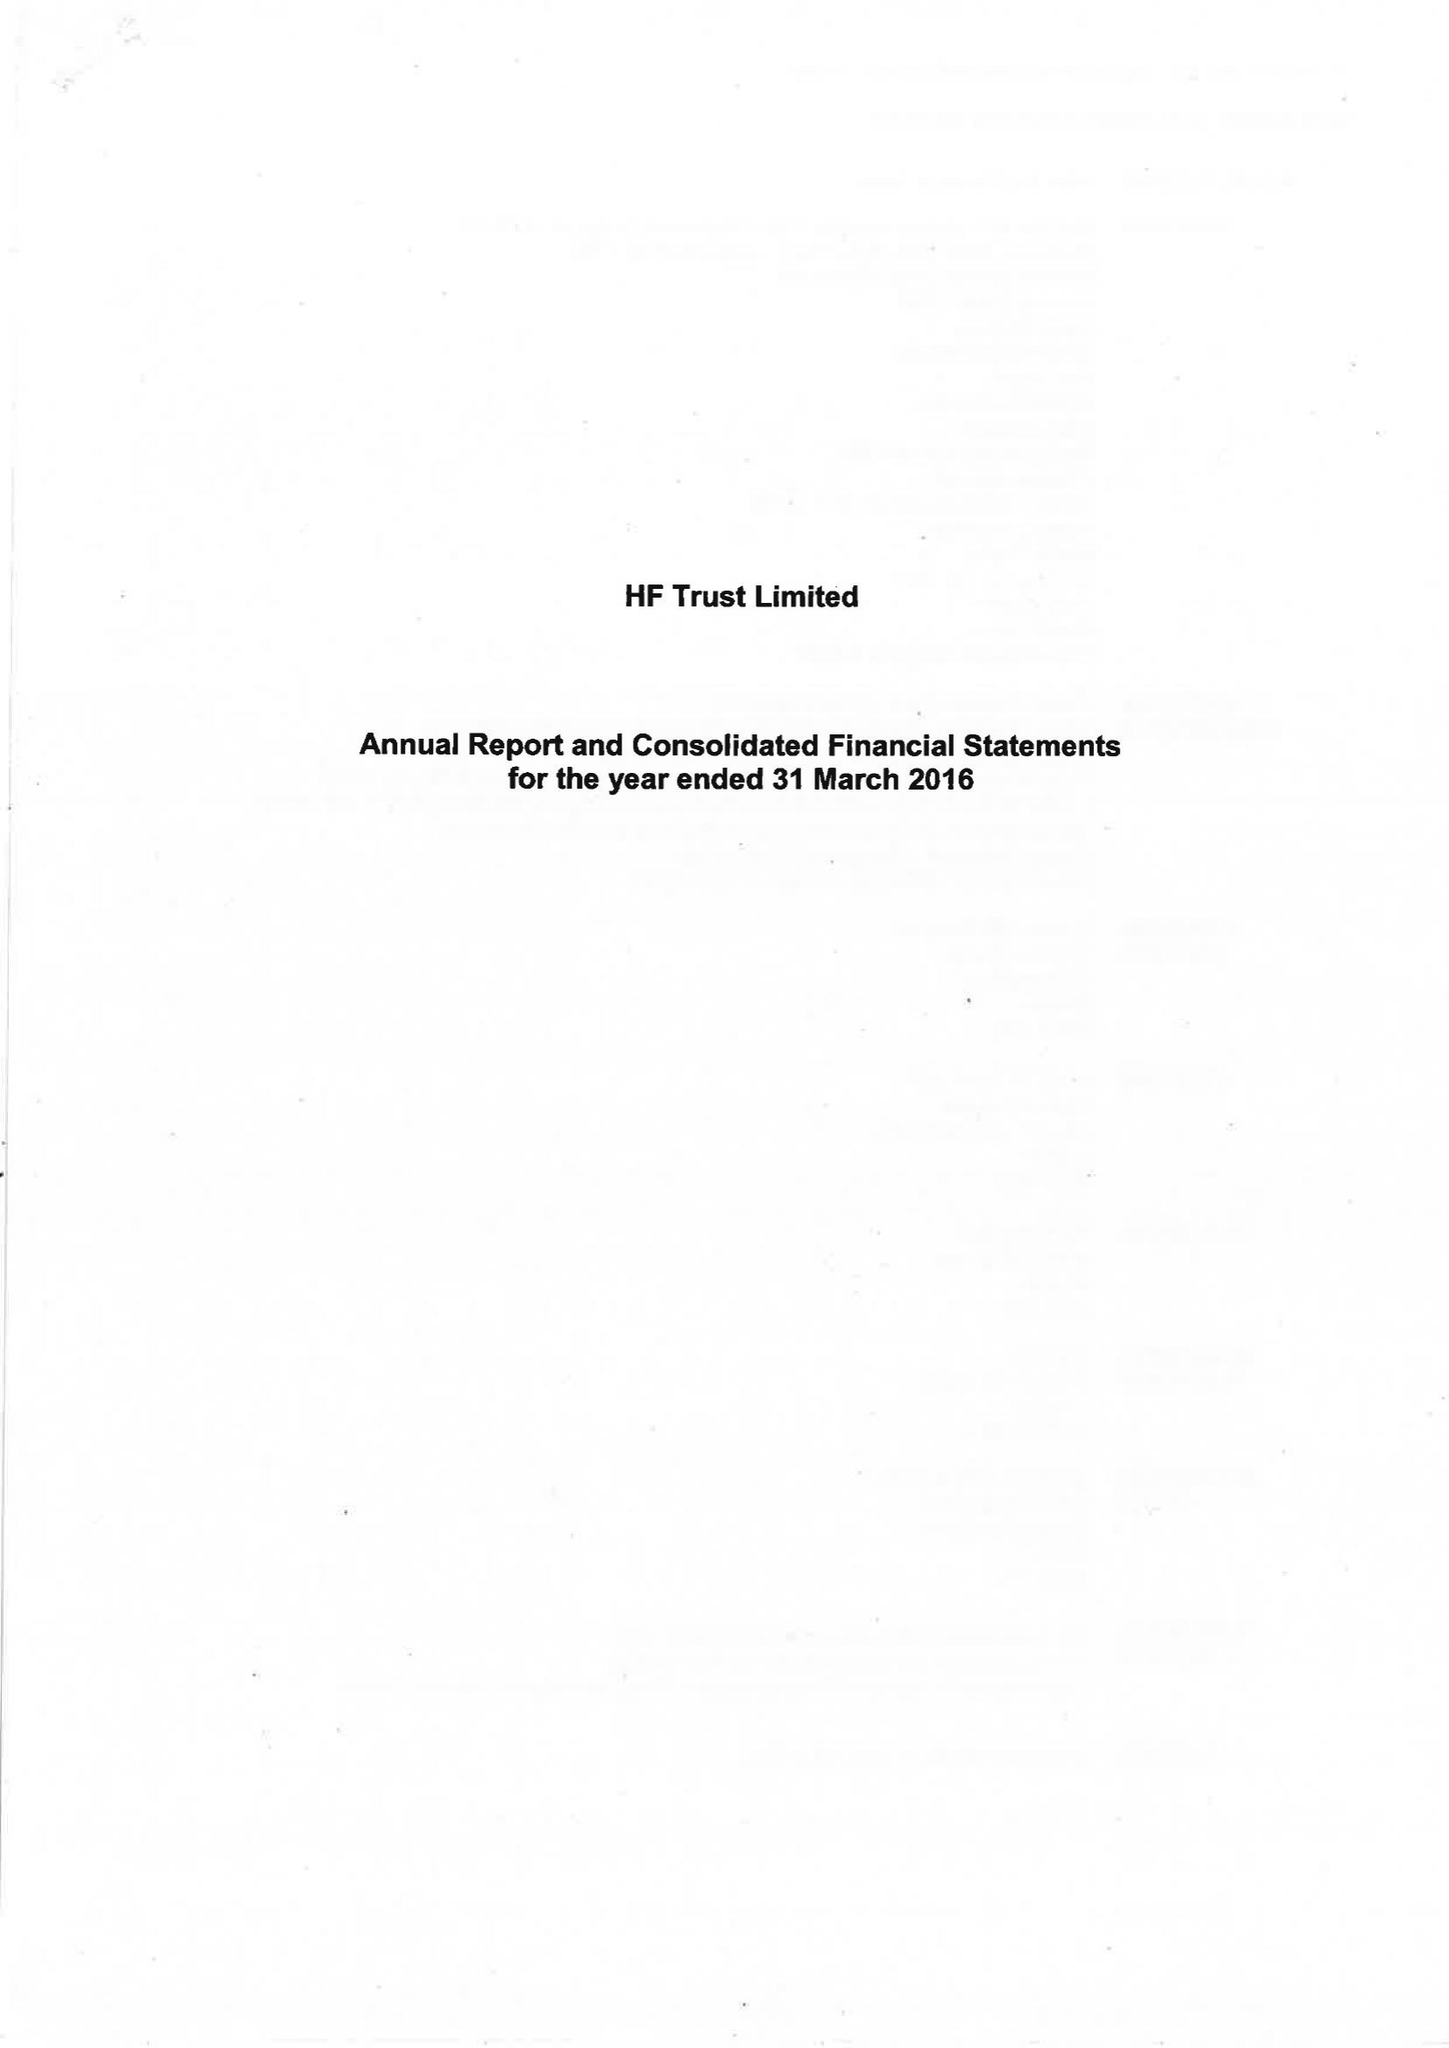What is the value for the charity_number?
Answer the question using a single word or phrase. 313069 